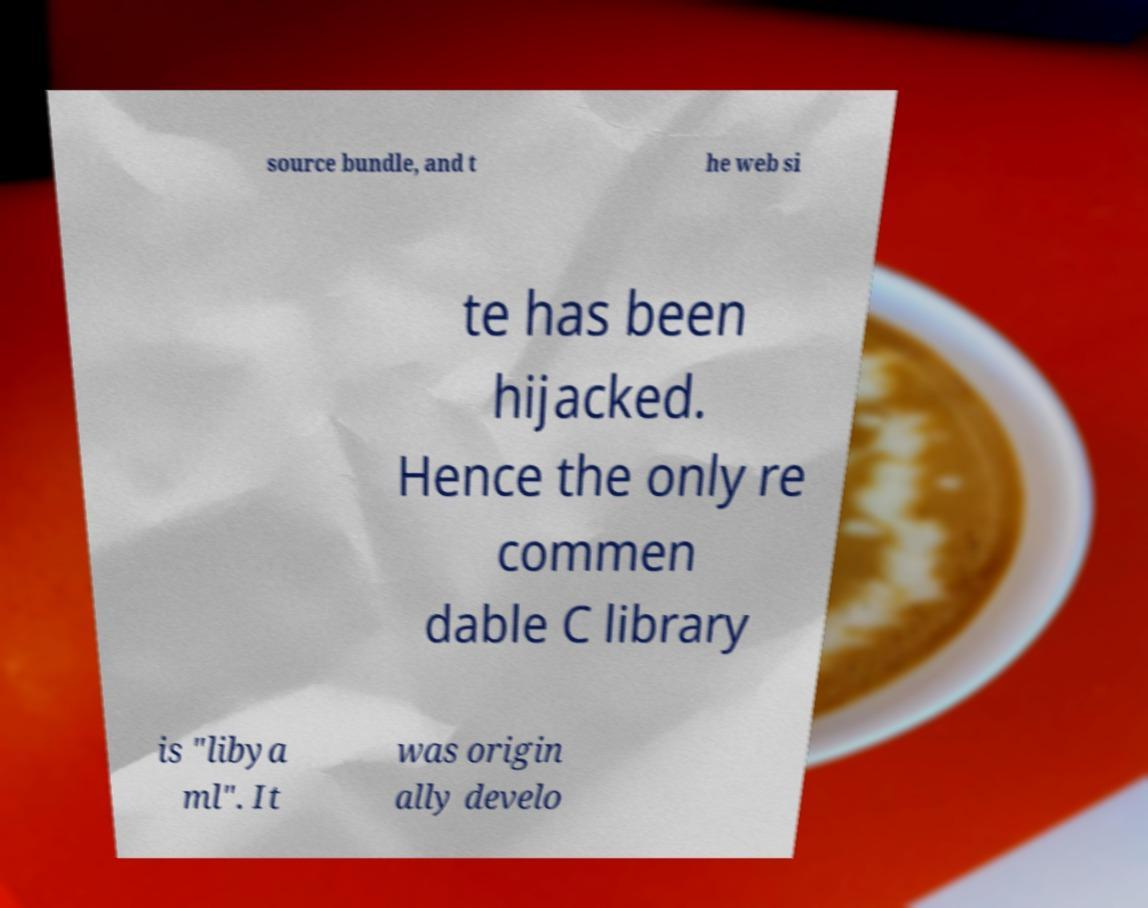I need the written content from this picture converted into text. Can you do that? source bundle, and t he web si te has been hijacked. Hence the only re commen dable C library is "libya ml". It was origin ally develo 